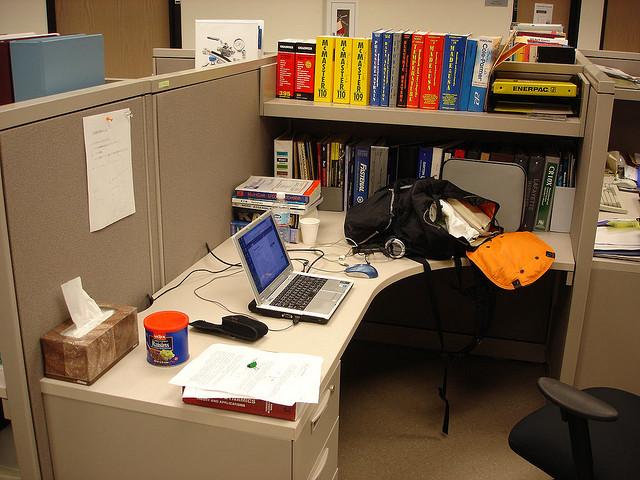How many people were sitting here?
Answer briefly. 1. Are there any snacks on the desk?
Quick response, please. Yes. What is the color of the tissue box?
Quick response, please. Brown. 